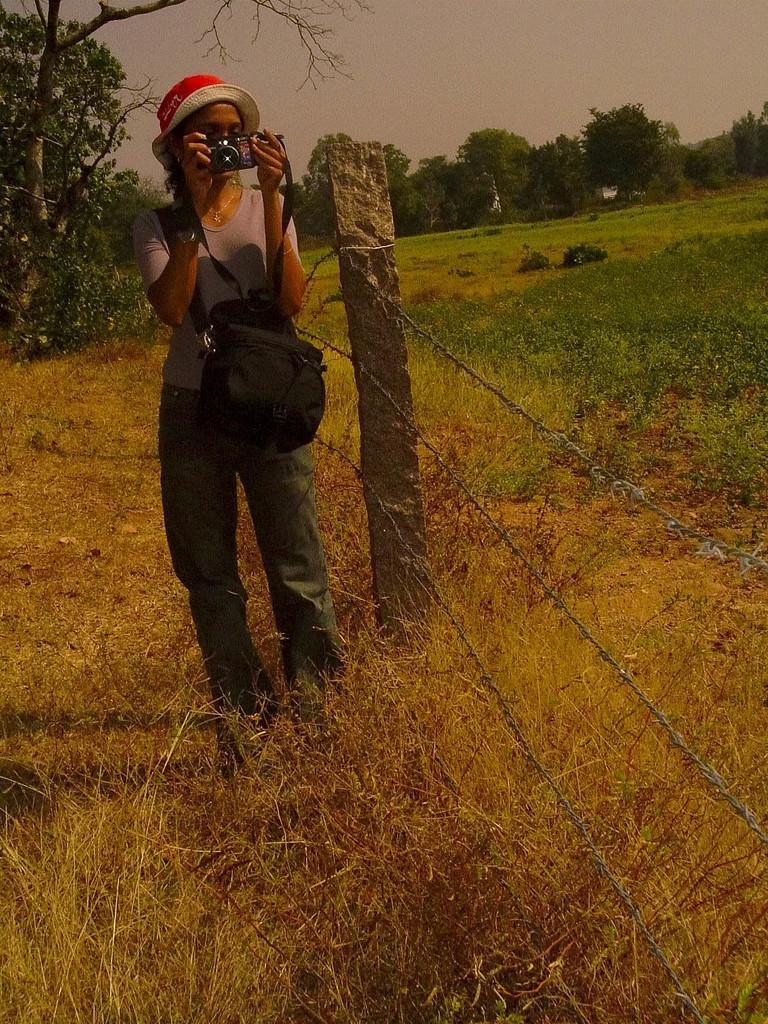In one or two sentences, can you explain what this image depicts? In the center of the image a lady is standing and wearing hat and bag and holding a camera. In the background of the image we can see the trees, fencing, grass and some plants. At the bottom of the image we can see the ground. At the top of the image we can see the sky. 